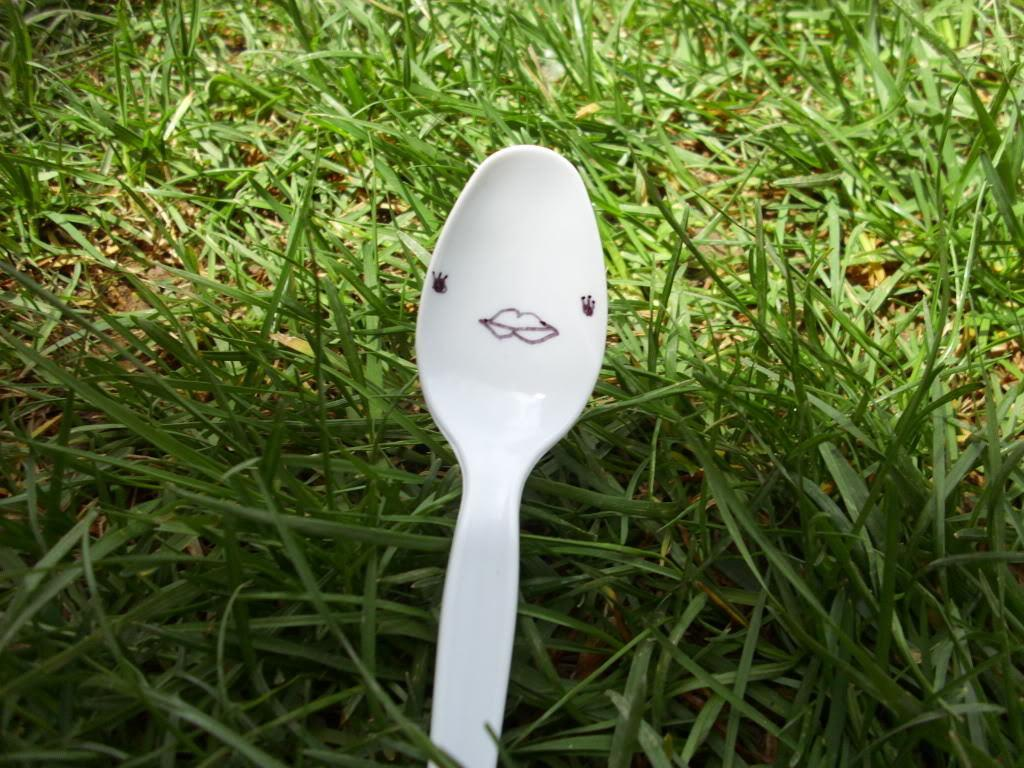What type of vegetation is visible in the image? There is grass in the image. What utensil can be seen in the image? There is a white-colored spoon in the image. Who is the creator of the map in the image? There is no map present in the image. How many ducks are visible in the image? There are no ducks present in the image. 